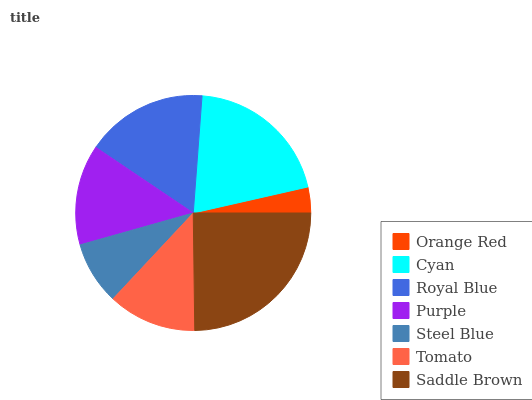Is Orange Red the minimum?
Answer yes or no. Yes. Is Saddle Brown the maximum?
Answer yes or no. Yes. Is Cyan the minimum?
Answer yes or no. No. Is Cyan the maximum?
Answer yes or no. No. Is Cyan greater than Orange Red?
Answer yes or no. Yes. Is Orange Red less than Cyan?
Answer yes or no. Yes. Is Orange Red greater than Cyan?
Answer yes or no. No. Is Cyan less than Orange Red?
Answer yes or no. No. Is Purple the high median?
Answer yes or no. Yes. Is Purple the low median?
Answer yes or no. Yes. Is Steel Blue the high median?
Answer yes or no. No. Is Orange Red the low median?
Answer yes or no. No. 